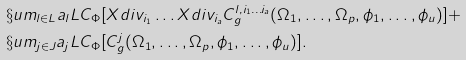<formula> <loc_0><loc_0><loc_500><loc_500>& \S u m _ { l \in L } a _ { l } L C _ { \Phi } [ X d i v _ { i _ { 1 } } \dots X d i v _ { i _ { a } } C ^ { l , i _ { 1 } \dots i _ { a } } _ { g } ( \Omega _ { 1 } , \dots , \Omega _ { p } , \phi _ { 1 } , \dots , \phi _ { u } ) ] + \\ & \S u m _ { j \in J } a _ { j } L C _ { \Phi } [ C ^ { j } _ { g } ( \Omega _ { 1 } , \dots , \Omega _ { p } , \phi _ { 1 } , \dots , \phi _ { u } ) ] .</formula> 